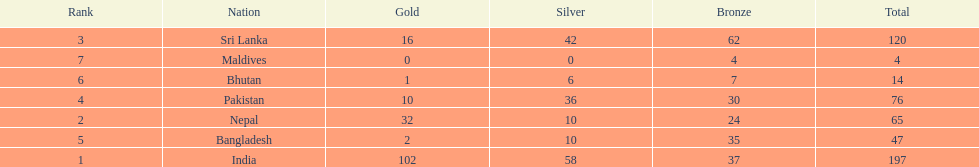What is the difference in total number of medals between india and nepal? 132. 